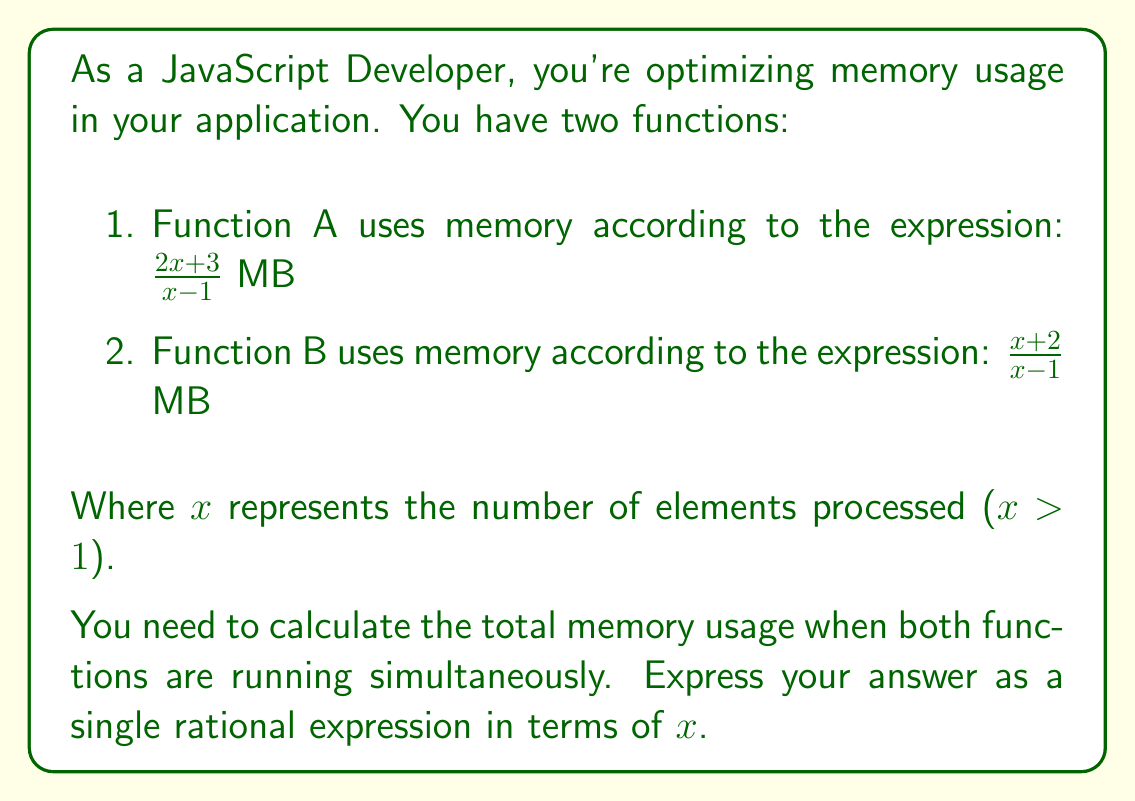Could you help me with this problem? To solve this problem, we need to add the two rational expressions representing the memory usage of each function. Let's approach this step-by-step:

1) We have two rational expressions:
   Function A: $\frac{2x + 3}{x - 1}$
   Function B: $\frac{x + 2}{x - 1}$

2) To add these expressions, we need a common denominator. Fortunately, they already have the same denominator $(x - 1)$, so we can directly add the numerators:

   $$\frac{2x + 3}{x - 1} + \frac{x + 2}{x - 1} = \frac{(2x + 3) + (x + 2)}{x - 1}$$

3) Let's simplify the numerator:
   $(2x + 3) + (x + 2) = 2x + x + 3 + 2 = 3x + 5$

4) Therefore, the total memory usage can be expressed as:

   $$\frac{3x + 5}{x - 1}$$

This rational expression represents the total memory usage in MB when both functions are running simultaneously, in terms of $x$ (the number of elements processed).
Answer: $\frac{3x + 5}{x - 1}$ MB 